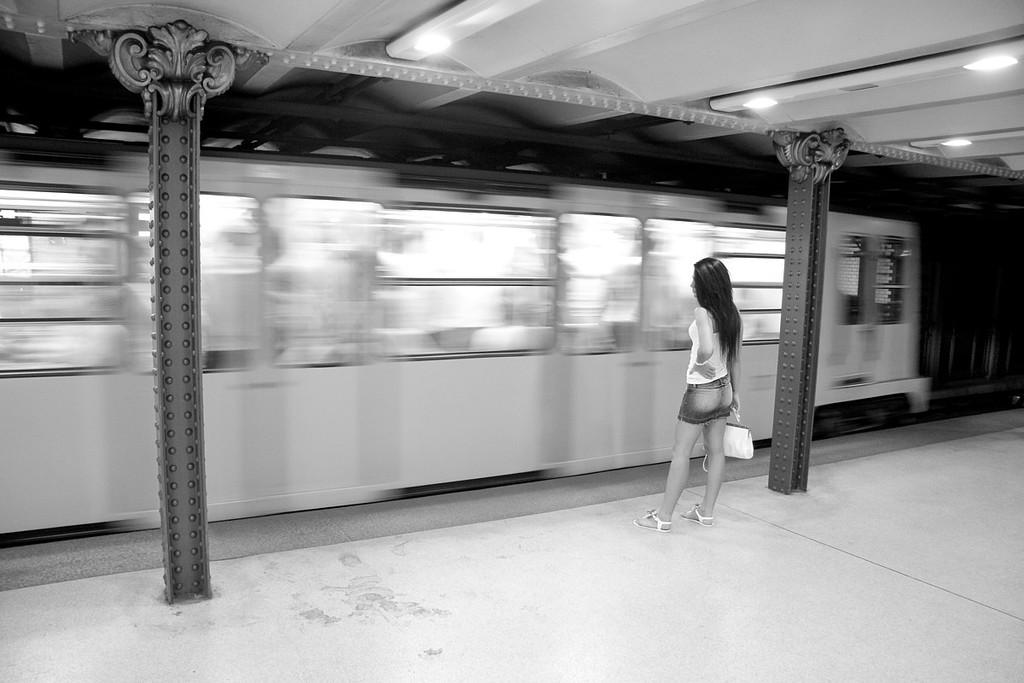What is the person in the image doing? The person is standing on the ground in the image. What is the person holding? The person is holding a purse. What architectural features can be seen in the image? There are pillars and a ceiling with lights in the image. What is visible in front of the person? There is a train visible in front of the person. Where are the snakes hiding in the image? There are no snakes present in the image. What type of underwear is the person wearing in the image? There is no information about the person's underwear in the image. 